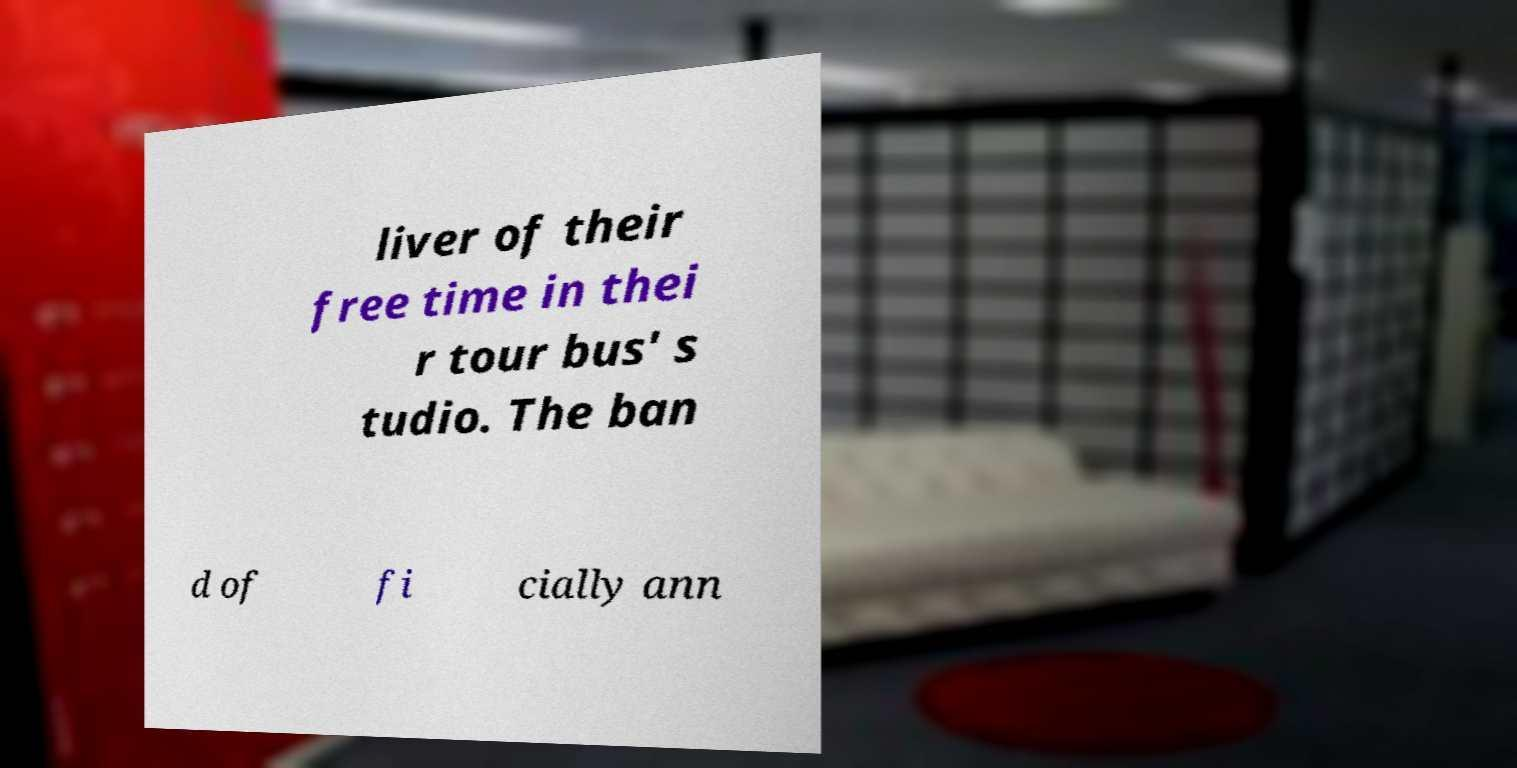There's text embedded in this image that I need extracted. Can you transcribe it verbatim? liver of their free time in thei r tour bus' s tudio. The ban d of fi cially ann 